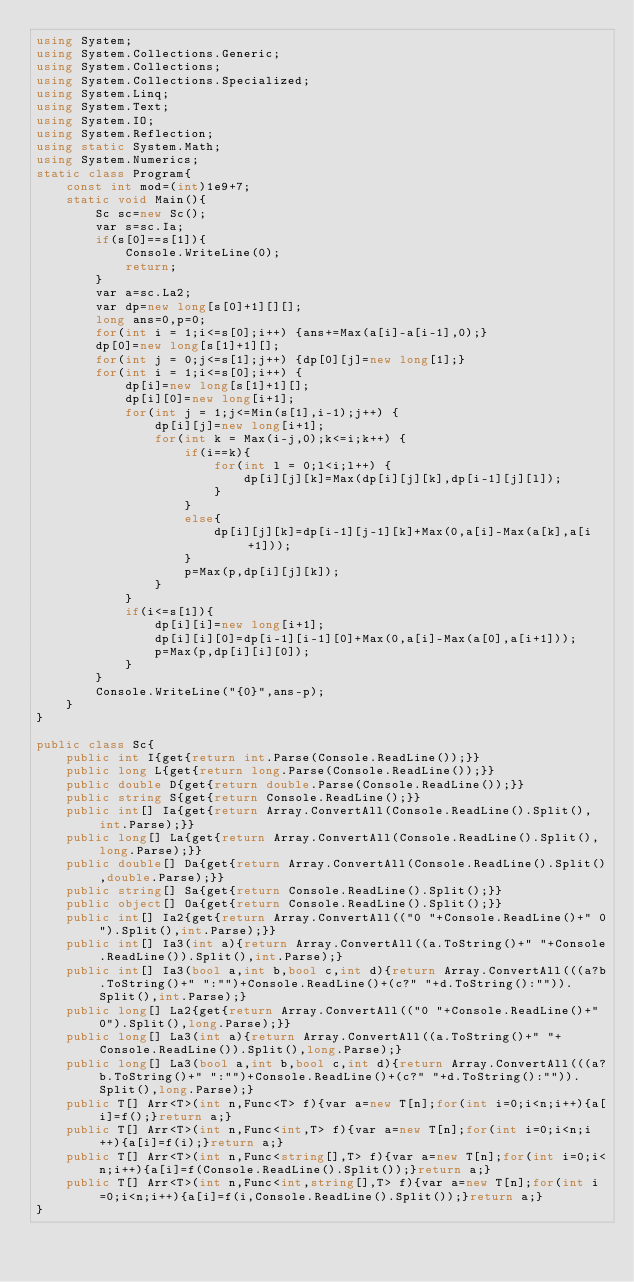Convert code to text. <code><loc_0><loc_0><loc_500><loc_500><_C#_>using System;
using System.Collections.Generic;
using System.Collections;
using System.Collections.Specialized;
using System.Linq;
using System.Text;
using System.IO;
using System.Reflection;
using static System.Math;
using System.Numerics;
static class Program{
	const int mod=(int)1e9+7;
	static void Main(){
		Sc sc=new Sc();
		var s=sc.Ia;
		if(s[0]==s[1]){
			Console.WriteLine(0);
			return;
		}
		var a=sc.La2;
		var dp=new long[s[0]+1][][];
		long ans=0,p=0;
		for(int i = 1;i<=s[0];i++) {ans+=Max(a[i]-a[i-1],0);}
		dp[0]=new long[s[1]+1][];
		for(int j = 0;j<=s[1];j++) {dp[0][j]=new long[1];}
		for(int i = 1;i<=s[0];i++) {
			dp[i]=new long[s[1]+1][];
			dp[i][0]=new long[i+1];
			for(int j = 1;j<=Min(s[1],i-1);j++) {
				dp[i][j]=new long[i+1];
				for(int k = Max(i-j,0);k<=i;k++) {
					if(i==k){
						for(int l = 0;l<i;l++) {
							dp[i][j][k]=Max(dp[i][j][k],dp[i-1][j][l]);
						}
					}
					else{
						dp[i][j][k]=dp[i-1][j-1][k]+Max(0,a[i]-Max(a[k],a[i+1]));
					}
					p=Max(p,dp[i][j][k]);
				}
			}
			if(i<=s[1]){
				dp[i][i]=new long[i+1];
				dp[i][i][0]=dp[i-1][i-1][0]+Max(0,a[i]-Max(a[0],a[i+1]));
				p=Max(p,dp[i][i][0]);
			}
		}
		Console.WriteLine("{0}",ans-p);
	}
}

public class Sc{
	public int I{get{return int.Parse(Console.ReadLine());}}
	public long L{get{return long.Parse(Console.ReadLine());}}
	public double D{get{return double.Parse(Console.ReadLine());}}
	public string S{get{return Console.ReadLine();}}
	public int[] Ia{get{return Array.ConvertAll(Console.ReadLine().Split(),int.Parse);}}
	public long[] La{get{return Array.ConvertAll(Console.ReadLine().Split(),long.Parse);}}
	public double[] Da{get{return Array.ConvertAll(Console.ReadLine().Split(),double.Parse);}}
	public string[] Sa{get{return Console.ReadLine().Split();}}
	public object[] Oa{get{return Console.ReadLine().Split();}}
	public int[] Ia2{get{return Array.ConvertAll(("0 "+Console.ReadLine()+" 0").Split(),int.Parse);}}
	public int[] Ia3(int a){return Array.ConvertAll((a.ToString()+" "+Console.ReadLine()).Split(),int.Parse);}
	public int[] Ia3(bool a,int b,bool c,int d){return Array.ConvertAll(((a?b.ToString()+" ":"")+Console.ReadLine()+(c?" "+d.ToString():"")).Split(),int.Parse);}
	public long[] La2{get{return Array.ConvertAll(("0 "+Console.ReadLine()+" 0").Split(),long.Parse);}}
	public long[] La3(int a){return Array.ConvertAll((a.ToString()+" "+Console.ReadLine()).Split(),long.Parse);}
	public long[] La3(bool a,int b,bool c,int d){return Array.ConvertAll(((a?b.ToString()+" ":"")+Console.ReadLine()+(c?" "+d.ToString():"")).Split(),long.Parse);}
	public T[] Arr<T>(int n,Func<T> f){var a=new T[n];for(int i=0;i<n;i++){a[i]=f();}return a;}
	public T[] Arr<T>(int n,Func<int,T> f){var a=new T[n];for(int i=0;i<n;i++){a[i]=f(i);}return a;}
	public T[] Arr<T>(int n,Func<string[],T> f){var a=new T[n];for(int i=0;i<n;i++){a[i]=f(Console.ReadLine().Split());}return a;}
	public T[] Arr<T>(int n,Func<int,string[],T> f){var a=new T[n];for(int i=0;i<n;i++){a[i]=f(i,Console.ReadLine().Split());}return a;}
}</code> 